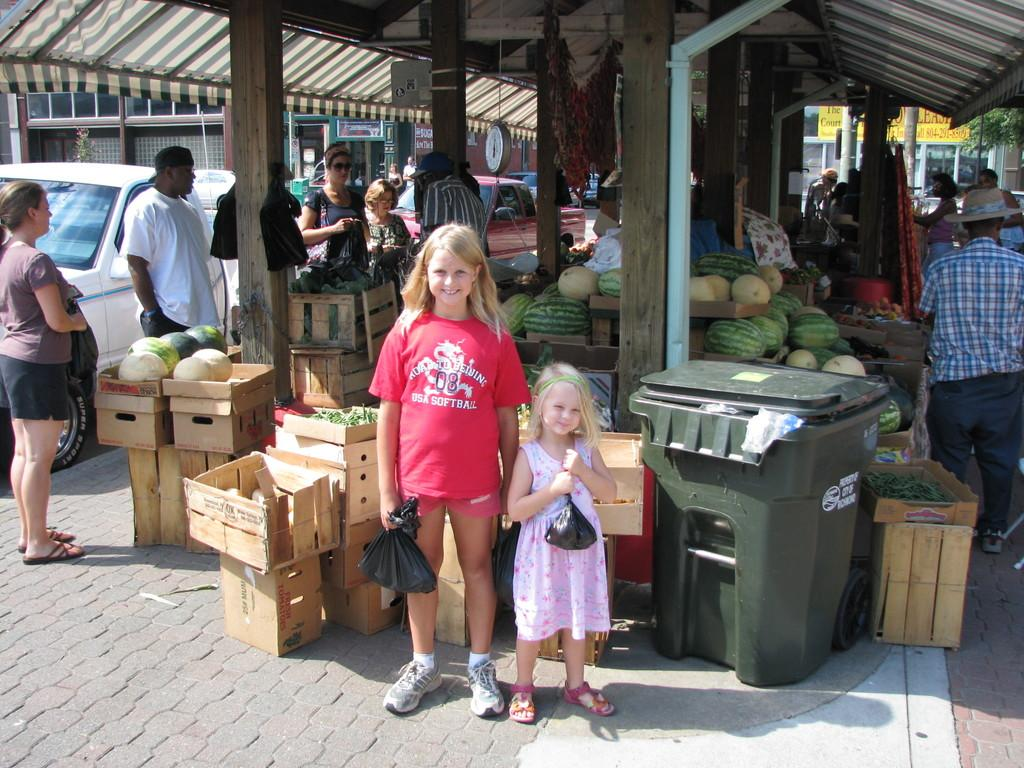<image>
Summarize the visual content of the image. A little girl is posing in front of a market wearing a red USA Softball shirt. 